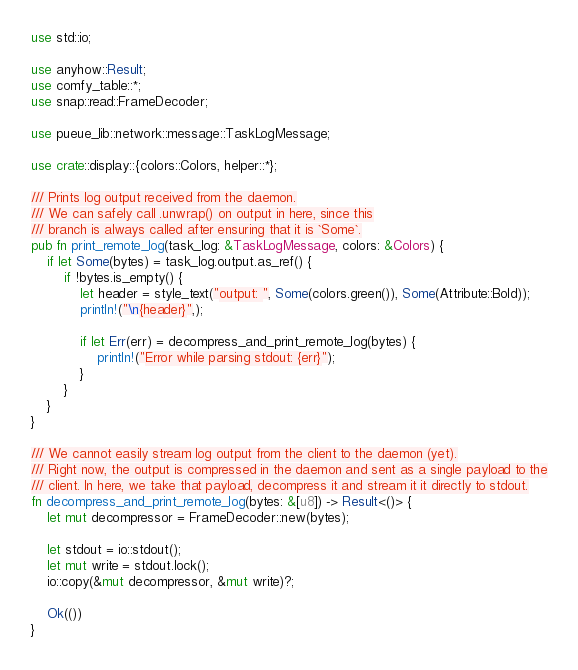Convert code to text. <code><loc_0><loc_0><loc_500><loc_500><_Rust_>use std::io;

use anyhow::Result;
use comfy_table::*;
use snap::read::FrameDecoder;

use pueue_lib::network::message::TaskLogMessage;

use crate::display::{colors::Colors, helper::*};

/// Prints log output received from the daemon.
/// We can safely call .unwrap() on output in here, since this
/// branch is always called after ensuring that it is `Some`.
pub fn print_remote_log(task_log: &TaskLogMessage, colors: &Colors) {
    if let Some(bytes) = task_log.output.as_ref() {
        if !bytes.is_empty() {
            let header = style_text("output: ", Some(colors.green()), Some(Attribute::Bold));
            println!("\n{header}",);

            if let Err(err) = decompress_and_print_remote_log(bytes) {
                println!("Error while parsing stdout: {err}");
            }
        }
    }
}

/// We cannot easily stream log output from the client to the daemon (yet).
/// Right now, the output is compressed in the daemon and sent as a single payload to the
/// client. In here, we take that payload, decompress it and stream it it directly to stdout.
fn decompress_and_print_remote_log(bytes: &[u8]) -> Result<()> {
    let mut decompressor = FrameDecoder::new(bytes);

    let stdout = io::stdout();
    let mut write = stdout.lock();
    io::copy(&mut decompressor, &mut write)?;

    Ok(())
}
</code> 